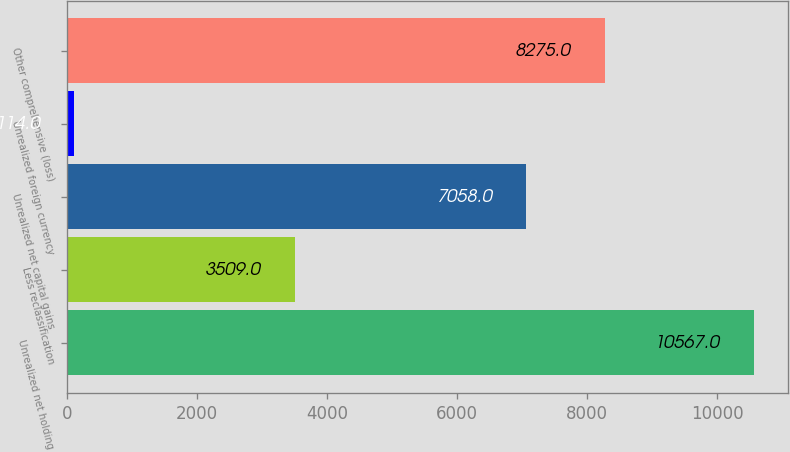Convert chart to OTSL. <chart><loc_0><loc_0><loc_500><loc_500><bar_chart><fcel>Unrealized net holding<fcel>Less reclassification<fcel>Unrealized net capital gains<fcel>Unrealized foreign currency<fcel>Other comprehensive (loss)<nl><fcel>10567<fcel>3509<fcel>7058<fcel>114<fcel>8275<nl></chart> 